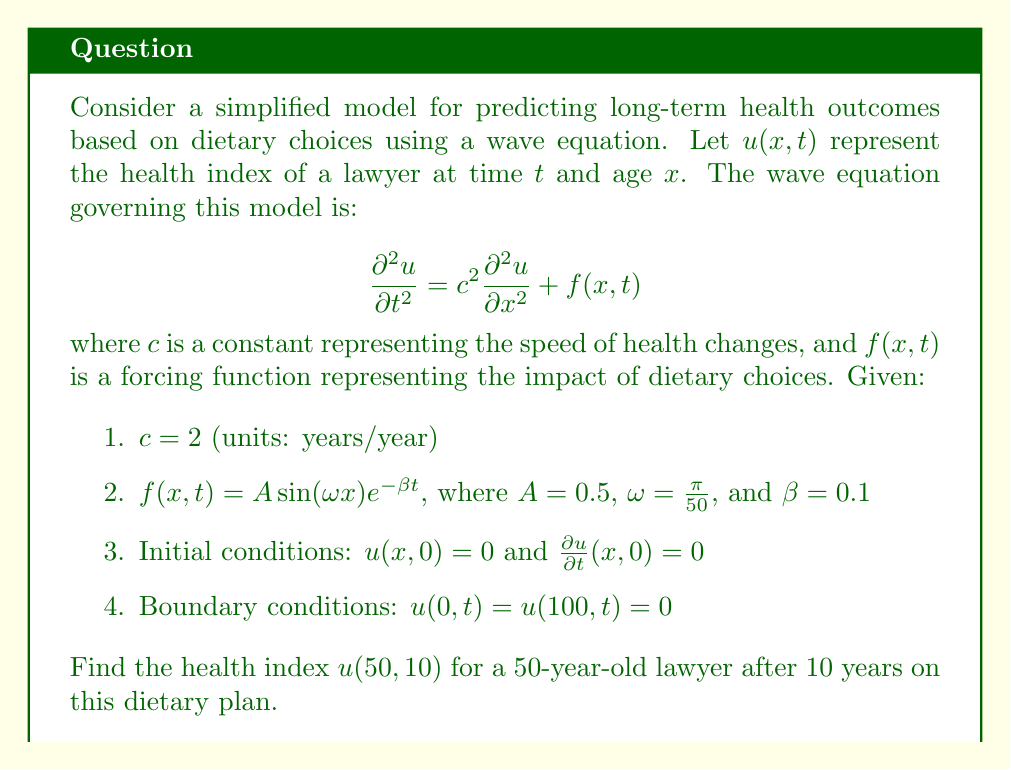Provide a solution to this math problem. To solve this problem, we need to use the method of separation of variables and Fourier series expansion. Let's break it down step by step:

1) First, we seek a solution of the form $u(x,t) = X(x)T(t)$.

2) Substituting this into the homogeneous equation (ignoring $f(x,t)$ for now):

   $$X(x)T''(t) = c^2 X''(x)T(t)$$

3) Separating variables:

   $$\frac{T''(t)}{c^2T(t)} = \frac{X''(x)}{X(x)} = -\lambda$$

4) This gives us two ordinary differential equations:

   $$X''(x) + \lambda X(x) = 0$$
   $$T''(t) + c^2\lambda T(t) = 0$$

5) Given the boundary conditions, we have $\lambda_n = (\frac{n\pi}{100})^2$ and $X_n(x) = \sin(\frac{n\pi x}{100})$ for $n = 1, 2, 3, ...$

6) The general solution for $T_n(t)$ is:

   $$T_n(t) = A_n \cos(\frac{2n\pi t}{100}) + B_n \sin(\frac{2n\pi t}{100})$$

7) Now, we need to consider the particular solution due to $f(x,t)$. We can express $f(x,t)$ as a Fourier series:

   $$f(x,t) = \sum_{n=1}^{\infty} F_n(t) \sin(\frac{n\pi x}{100})$$

   where $F_n(t) = \frac{2A}{100} \int_0^{100} \sin(\frac{\pi x}{50}) e^{-\beta t} \sin(\frac{n\pi x}{100}) dx$

8) Solving this integral, we find that $F_n(t)$ is non-zero only for $n = 2$:

   $$F_2(t) = 0.5 e^{-0.1t}$$

9) The particular solution for $n = 2$ is:

   $$u_p(x,t) = \frac{0.5}{(\frac{4\pi}{100})^2 + 0.1^2} (1 - e^{-0.1t} \cos(\frac{4\pi t}{100})) \sin(\frac{2\pi x}{100})$$

10) Combining the homogeneous and particular solutions, and applying initial conditions:

    $$u(x,t) = u_p(x,t) + \sum_{n=1}^{\infty} B_n \sin(\frac{2n\pi t}{100}) \sin(\frac{n\pi x}{100})$$

    where $B_n = 0$ for $n \neq 2$ and $B_2 = -\frac{0.5}{(\frac{4\pi}{100})^2 + 0.1^2}$

11) Therefore, the final solution is:

    $$u(x,t) = \frac{0.5}{(\frac{4\pi}{100})^2 + 0.1^2} (1 - e^{-0.1t} \cos(\frac{4\pi t}{100})) \sin(\frac{2\pi x}{100})$$

12) Evaluating at $x = 50$ and $t = 10$:

    $$u(50,10) = \frac{0.5}{(\frac{4\pi}{100})^2 + 0.1^2} (1 - e^{-1} \cos(4\pi)) \sin(\pi)$$
Answer: $u(50,10) = 0$

The health index for a 50-year-old lawyer after 10 years on this dietary plan is 0. This is because $\sin(\pi) = 0$, which makes the entire expression zero regardless of the other terms. 